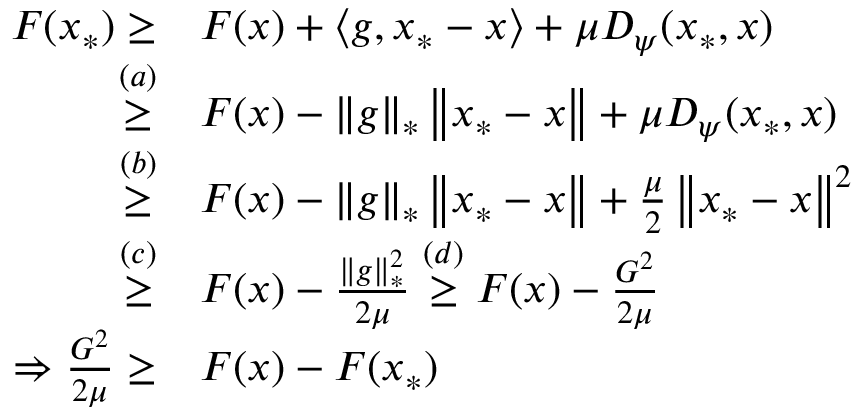Convert formula to latex. <formula><loc_0><loc_0><loc_500><loc_500>\begin{array} { r l } { F ( x _ { * } ) \geq } & { F ( x ) + \langle g , x _ { * } - x \rangle + \mu D _ { \psi } ( x _ { * } , x ) } \\ { \overset { ( a ) } { \geq } } & { F ( x ) - \left \| g \right \| _ { * } \left \| x _ { * } - x \right \| + \mu D _ { \psi } ( x _ { * } , x ) } \\ { \overset { ( b ) } { \geq } } & { F ( x ) - \left \| g \right \| _ { * } \left \| x _ { * } - x \right \| + \frac { \mu } { 2 } \left \| x _ { * } - x \right \| ^ { 2 } } \\ { \overset { ( c ) } { \geq } } & { F ( x ) - \frac { \left \| g \right \| _ { * } ^ { 2 } } { 2 \mu } \overset { ( d ) } { \geq } F ( x ) - \frac { G ^ { 2 } } { 2 \mu } } \\ { \Rightarrow \frac { G ^ { 2 } } { 2 \mu } \geq } & { F ( x ) - F ( x _ { * } ) } \end{array}</formula> 